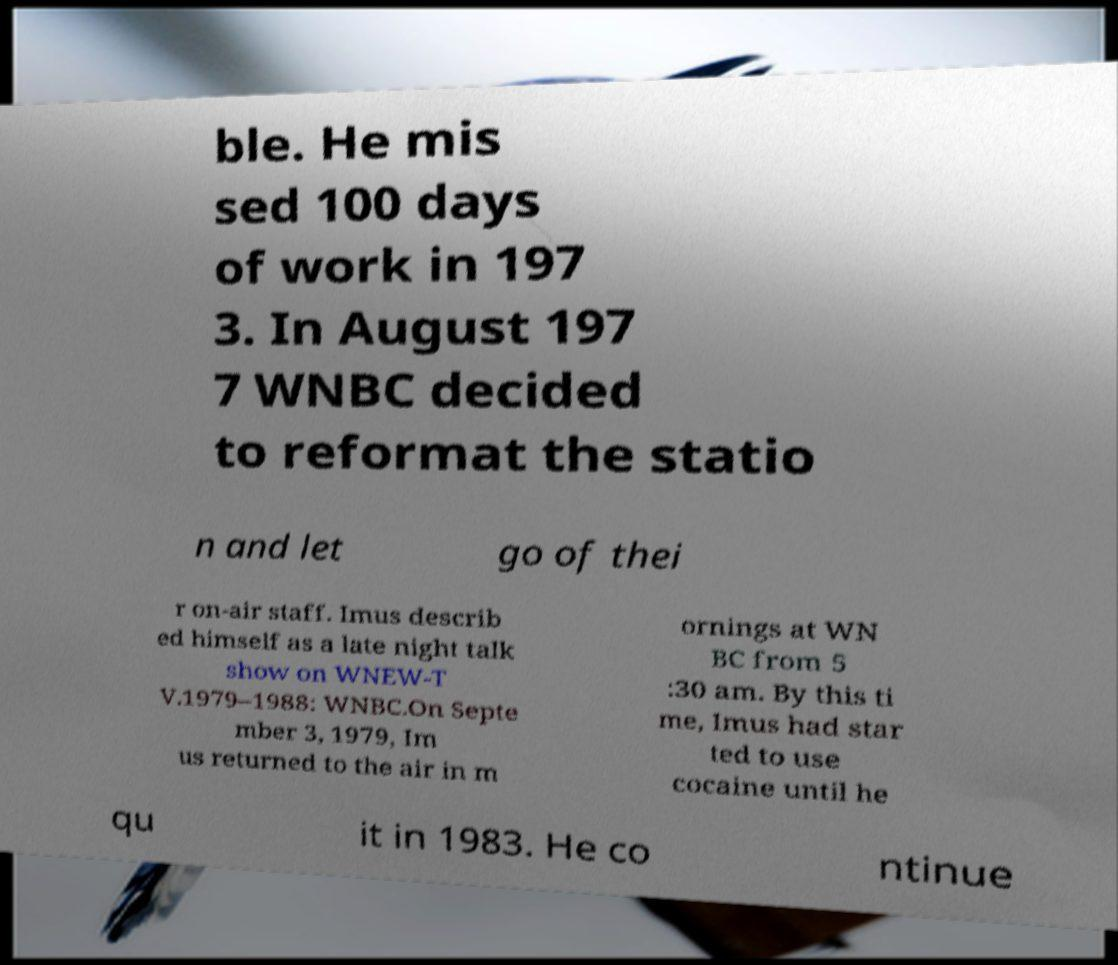Could you extract and type out the text from this image? ble. He mis sed 100 days of work in 197 3. In August 197 7 WNBC decided to reformat the statio n and let go of thei r on-air staff. Imus describ ed himself as a late night talk show on WNEW-T V.1979–1988: WNBC.On Septe mber 3, 1979, Im us returned to the air in m ornings at WN BC from 5 :30 am. By this ti me, Imus had star ted to use cocaine until he qu it in 1983. He co ntinue 